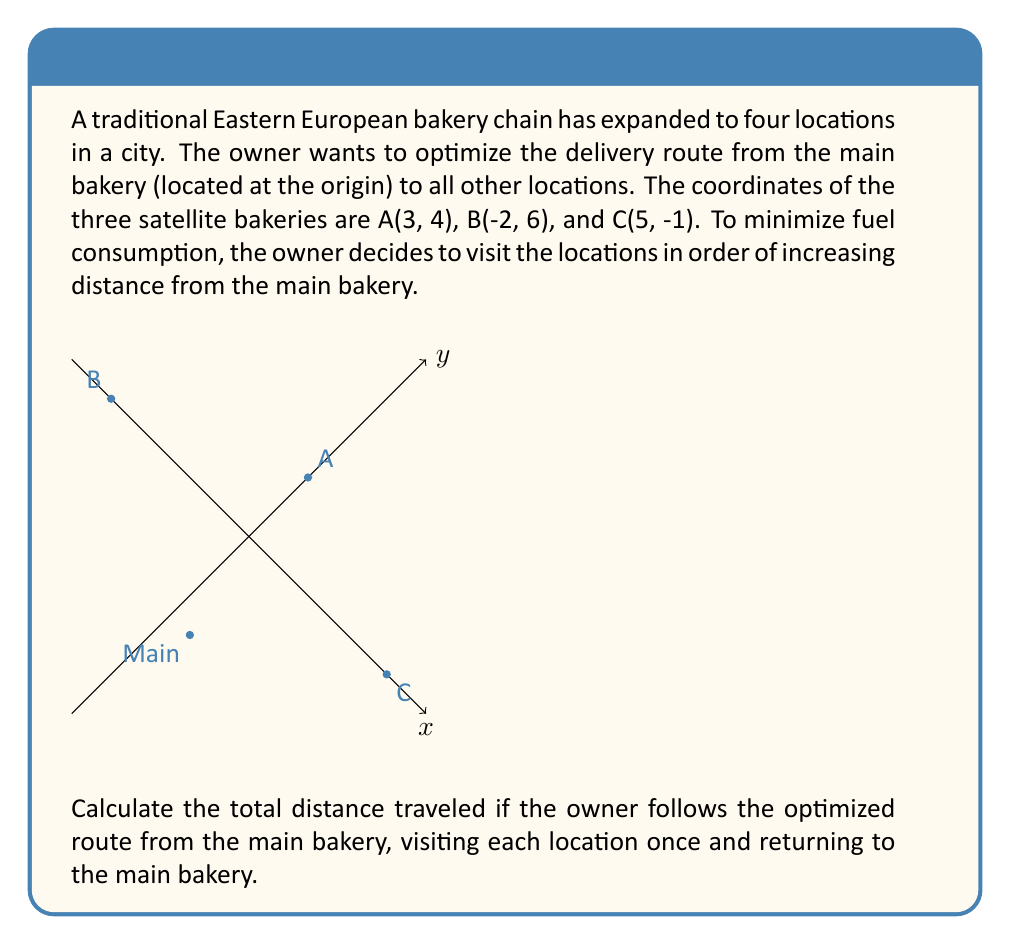Give your solution to this math problem. Let's approach this step-by-step:

1) First, we need to calculate the distance of each bakery from the main location. We can do this using the distance formula:
   $d = \sqrt{(x_2-x_1)^2 + (y_2-y_1)^2}$

2) For bakery A: $d_A = \sqrt{(3-0)^2 + (4-0)^2} = \sqrt{9 + 16} = \sqrt{25} = 5$

3) For bakery B: $d_B = \sqrt{(-2-0)^2 + (6-0)^2} = \sqrt{4 + 36} = \sqrt{40} \approx 6.32$

4) For bakery C: $d_C = \sqrt{(5-0)^2 + (-1-0)^2} = \sqrt{25 + 1} = \sqrt{26} \approx 5.10$

5) Ordering these from closest to farthest: A, C, B

6) Now, let's calculate the distances between consecutive points in this order:
   - Main to A: 5 (already calculated)
   - A to C: $\sqrt{(5-3)^2 + (-1-4)^2} = \sqrt{4 + 25} = \sqrt{29} \approx 5.39$
   - C to B: $\sqrt{(-2-5)^2 + (6-(-1))^2} = \sqrt{49 + 49} = \sqrt{98} \approx 9.90$
   - B back to Main: 6.32 (already calculated)

7) The total distance is the sum of these distances:
   $5 + 5.39 + 9.90 + 6.32 = 26.61$

Therefore, the total distance traveled is approximately 26.61 units.
Answer: 26.61 units 